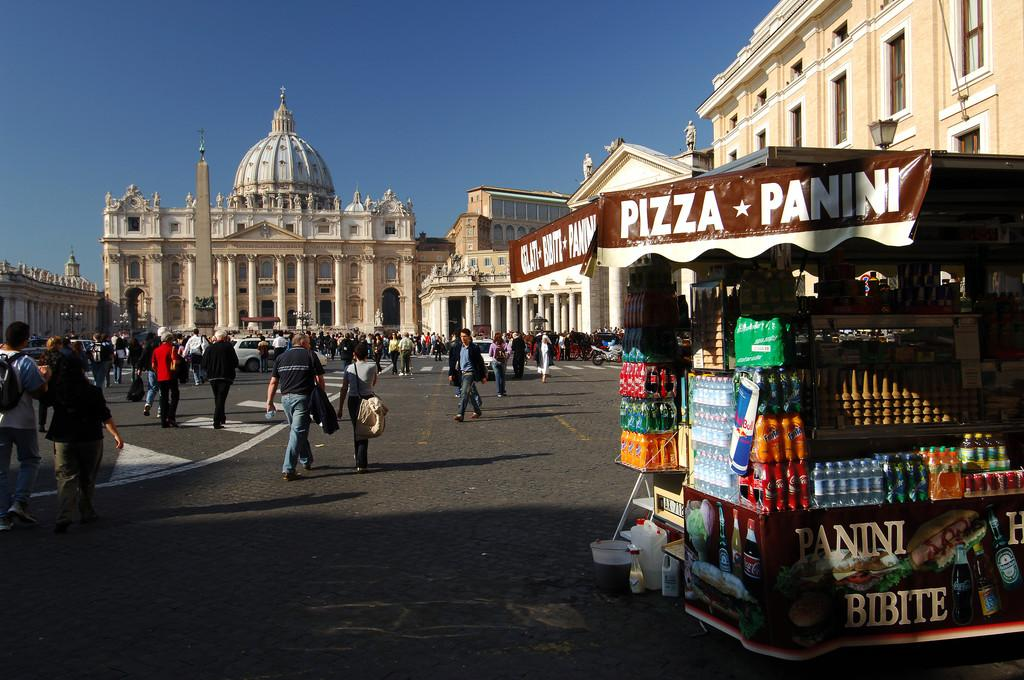What type of structure is the main focus of the image? There is a castle in the image. What other structures can be seen in the image? There are buildings in the image. Are there any living beings present in the image? Yes, there are people in the image. What else can be found in the image? There are vehicles and a store with food items in the image. What can be seen in the background of the image? The sky is visible in the background of the image. Where is the goat grazing in the image? There is no goat present in the image. What type of cloth is draped over the mountain in the image? There is no mountain or cloth present in the image. 